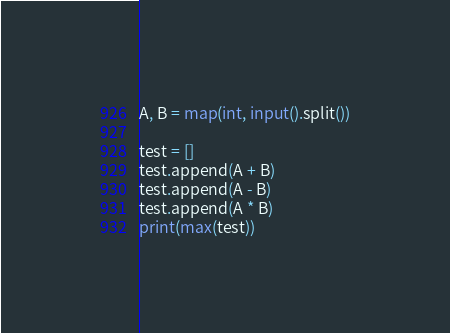<code> <loc_0><loc_0><loc_500><loc_500><_Python_>A, B = map(int, input().split())

test = []
test.append(A + B)
test.append(A - B)
test.append(A * B)
print(max(test))</code> 